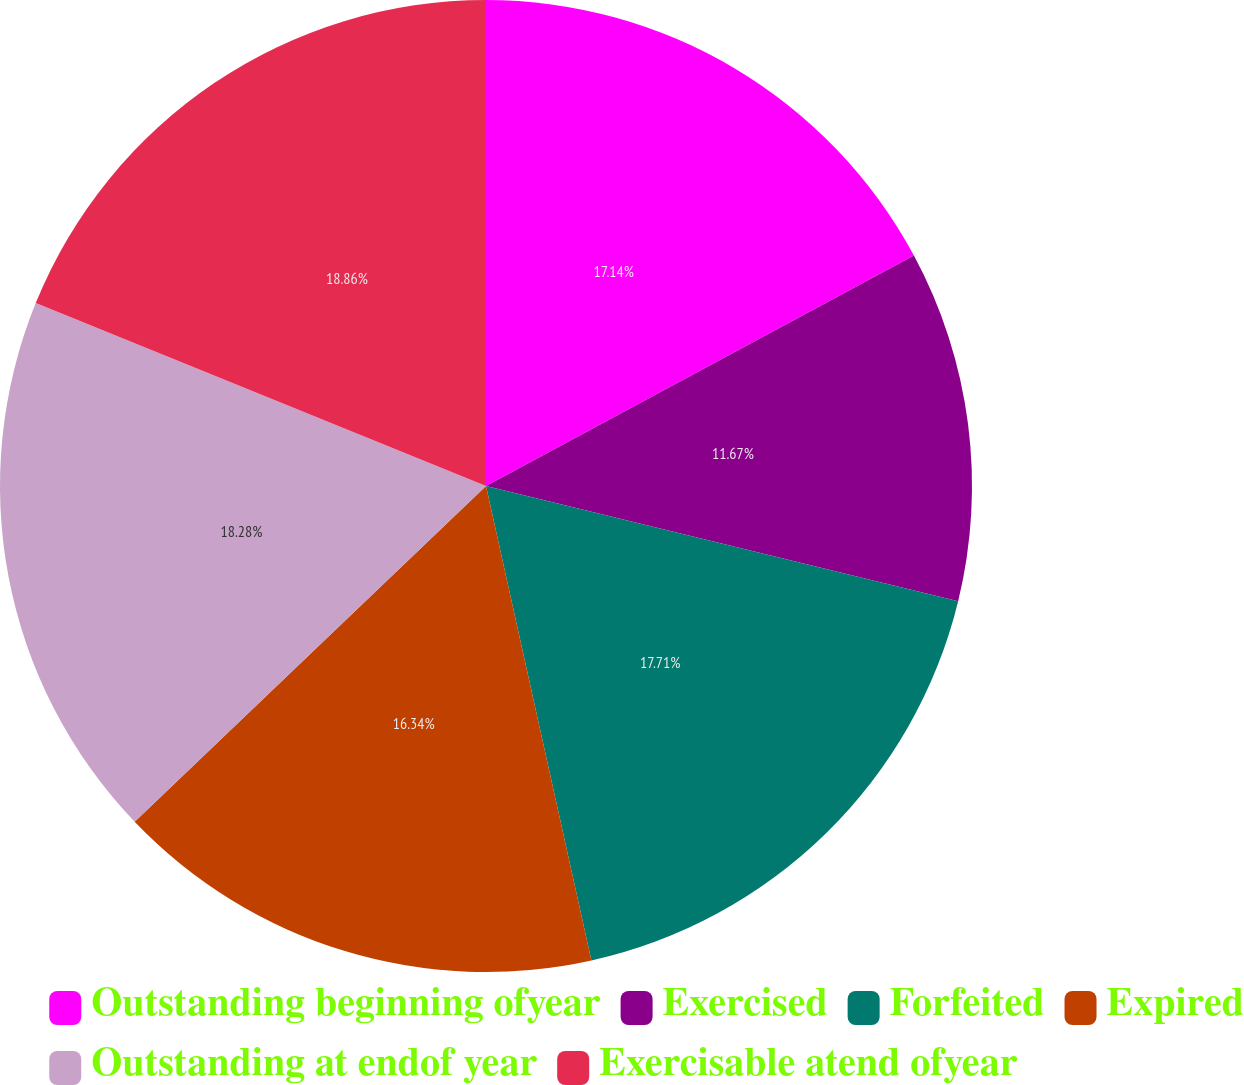Convert chart. <chart><loc_0><loc_0><loc_500><loc_500><pie_chart><fcel>Outstanding beginning ofyear<fcel>Exercised<fcel>Forfeited<fcel>Expired<fcel>Outstanding at endof year<fcel>Exercisable atend ofyear<nl><fcel>17.14%<fcel>11.67%<fcel>17.71%<fcel>16.34%<fcel>18.28%<fcel>18.86%<nl></chart> 